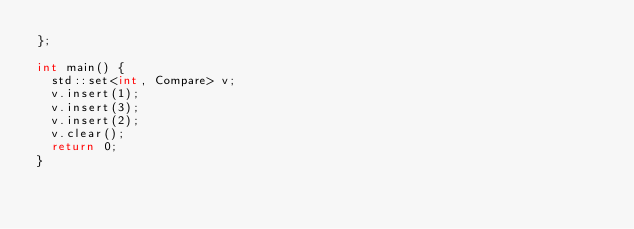<code> <loc_0><loc_0><loc_500><loc_500><_C++_>};

int main() {
  std::set<int, Compare> v;
  v.insert(1);
  v.insert(3);
  v.insert(2);
  v.clear();
  return 0;
}
</code> 